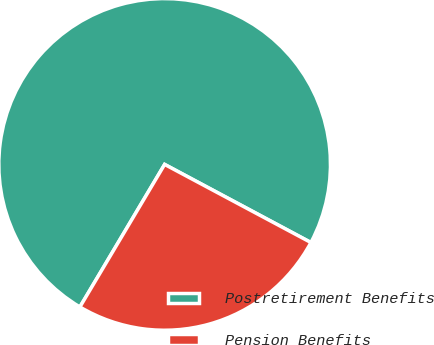Convert chart. <chart><loc_0><loc_0><loc_500><loc_500><pie_chart><fcel>Postretirement Benefits<fcel>Pension Benefits<nl><fcel>74.27%<fcel>25.73%<nl></chart> 